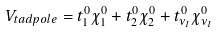<formula> <loc_0><loc_0><loc_500><loc_500>V _ { t a d p o l e } = t _ { 1 } ^ { 0 } \chi _ { 1 } ^ { 0 } + t _ { 2 } ^ { 0 } \chi _ { 2 } ^ { 0 } + t _ { \nu _ { I } } ^ { 0 } \chi _ { \nu _ { I } } ^ { 0 }</formula> 